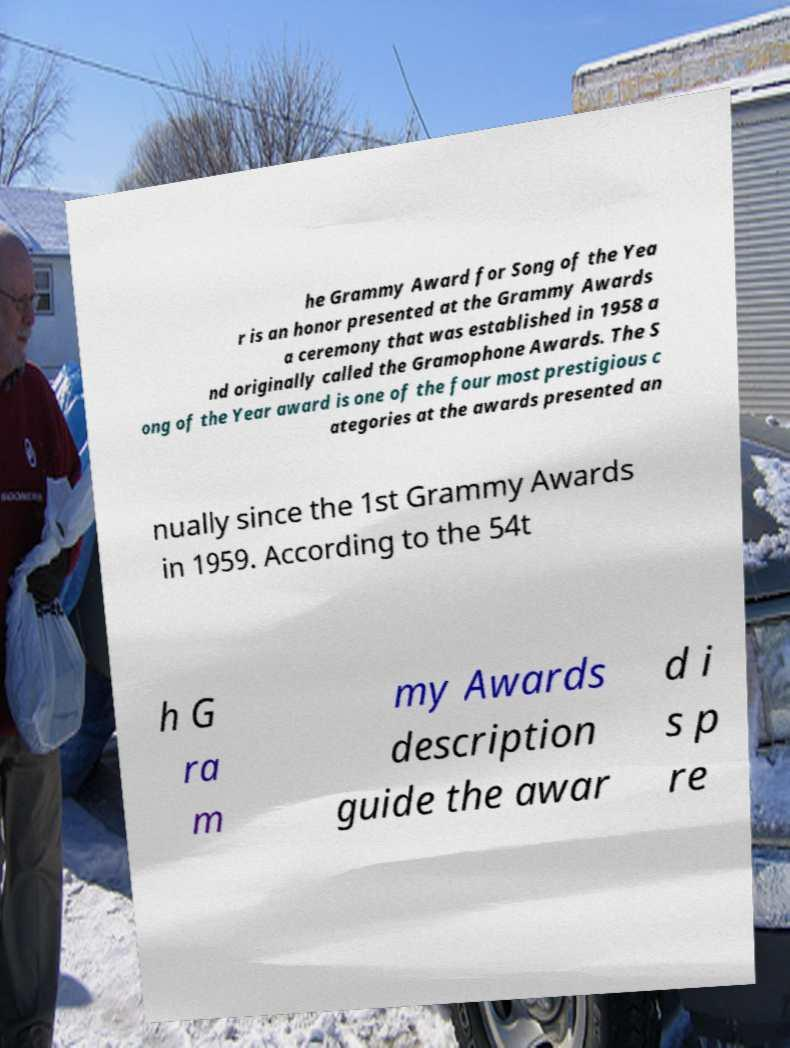Can you read and provide the text displayed in the image?This photo seems to have some interesting text. Can you extract and type it out for me? he Grammy Award for Song of the Yea r is an honor presented at the Grammy Awards a ceremony that was established in 1958 a nd originally called the Gramophone Awards. The S ong of the Year award is one of the four most prestigious c ategories at the awards presented an nually since the 1st Grammy Awards in 1959. According to the 54t h G ra m my Awards description guide the awar d i s p re 